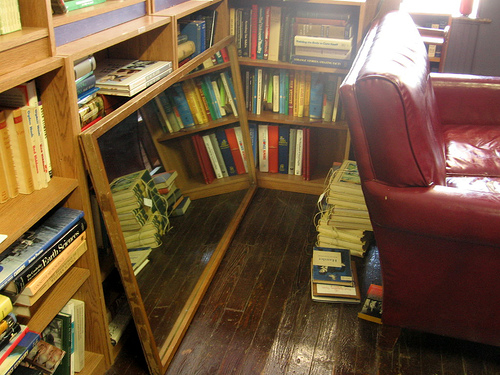<image>
Is there a book on the floor? No. The book is not positioned on the floor. They may be near each other, but the book is not supported by or resting on top of the floor. 